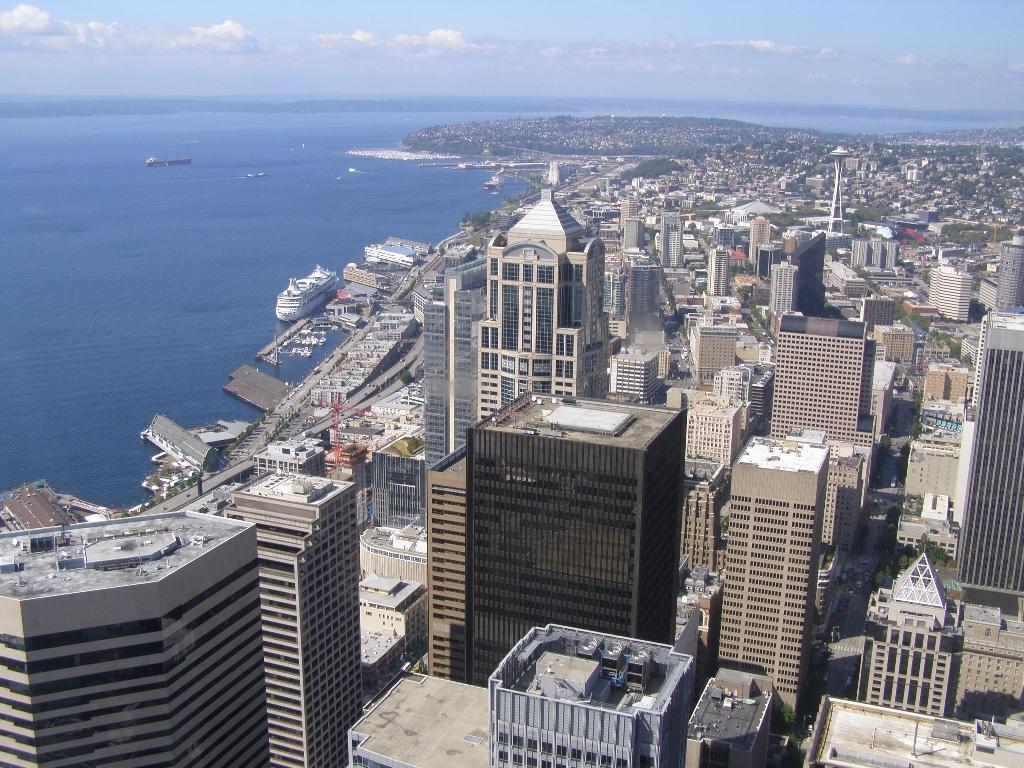Please provide a concise description of this image. In this picture we can see buildings, trees, and a pole. There are ships on the water. In the background there is sky with clouds. 